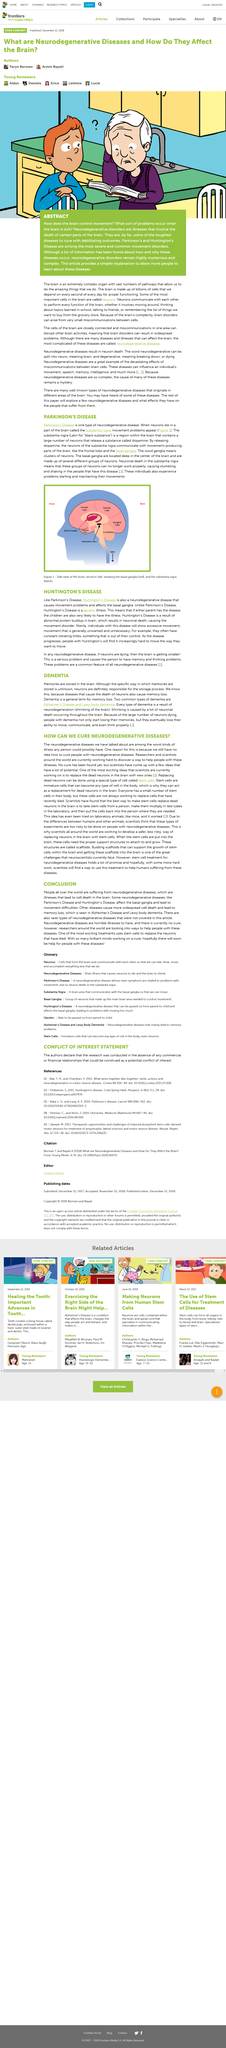Indicate a few pertinent items in this graphic. Scaffolds are support structures placed in the brain for the purpose of allowing stem cells to attach and grow. The term "ganglia" refers to clusters of neurons that function together as a unit in the nervous system. It is determined by scientists that the best way to replace dead neurons is by using stem cells. The substantia nigra is a region in the brain that contains neurons that release a substance called dopamine. The basal ganglia is located deep in the center of the brain, specifically whereabouts unknown to the general public. 